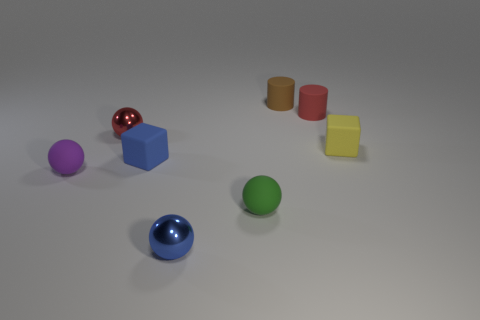What material is the purple sphere to the left of the tiny rubber cube on the right side of the blue rubber cube?
Ensure brevity in your answer.  Rubber. Is there a thing?
Provide a short and direct response. Yes. There is a red thing that is to the right of the sphere behind the tiny blue rubber block; how big is it?
Offer a very short reply. Small. Are there more green things in front of the blue metal thing than small cylinders on the left side of the brown cylinder?
Offer a terse response. No. How many spheres are either big cyan things or tiny red matte objects?
Ensure brevity in your answer.  0. There is a small blue object that is behind the tiny purple matte object; is it the same shape as the yellow thing?
Your answer should be compact. Yes. What is the color of the other rubber thing that is the same shape as the tiny green thing?
Your answer should be compact. Purple. What number of tiny red things have the same shape as the green object?
Provide a short and direct response. 1. What number of things are brown metal things or tiny objects that are left of the red metallic ball?
Give a very brief answer. 1. There is a ball that is in front of the blue rubber object and behind the tiny green thing; what is its size?
Offer a very short reply. Small. 